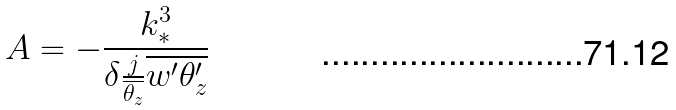Convert formula to latex. <formula><loc_0><loc_0><loc_500><loc_500>A = - \frac { k _ { * } ^ { 3 } } { \delta \frac { j } { \overline { \theta _ { z } } } \overline { w ^ { \prime } \theta _ { z } ^ { \prime } } }</formula> 